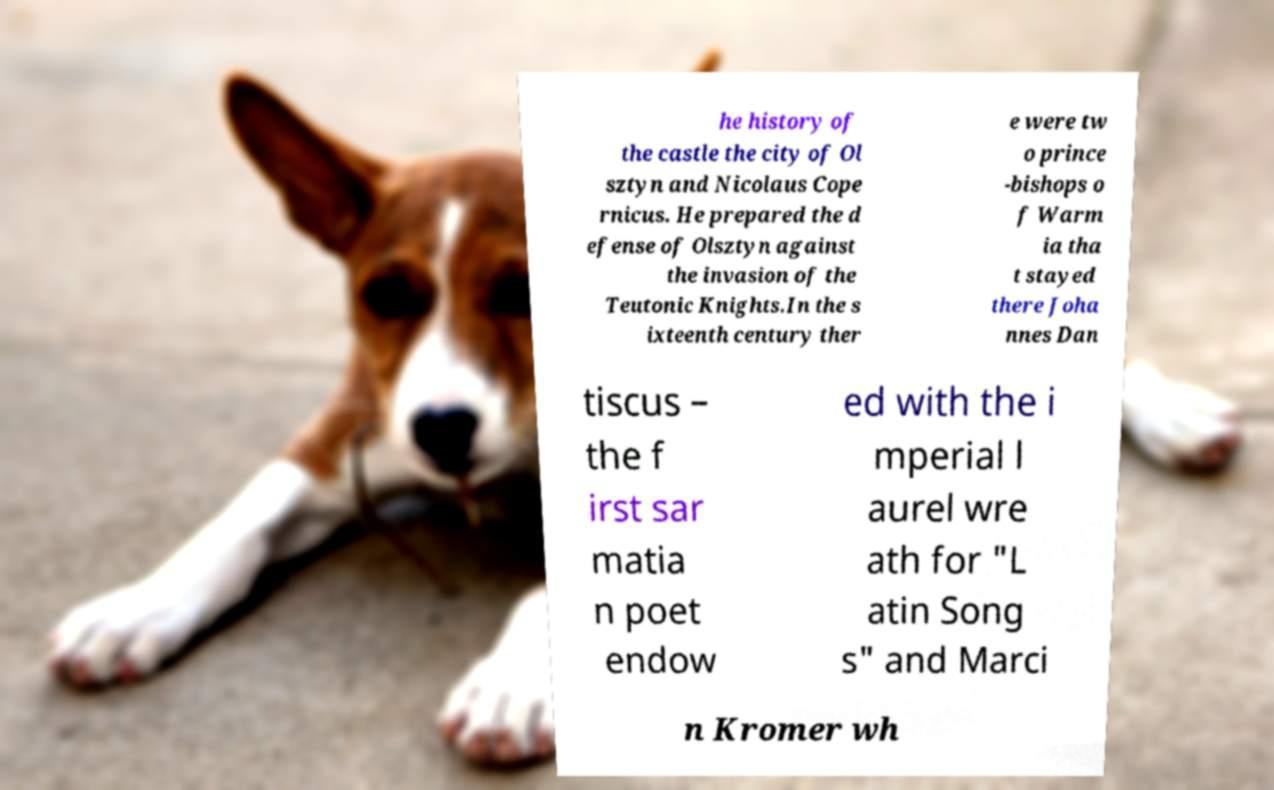I need the written content from this picture converted into text. Can you do that? he history of the castle the city of Ol sztyn and Nicolaus Cope rnicus. He prepared the d efense of Olsztyn against the invasion of the Teutonic Knights.In the s ixteenth century ther e were tw o prince -bishops o f Warm ia tha t stayed there Joha nnes Dan tiscus – the f irst sar matia n poet endow ed with the i mperial l aurel wre ath for "L atin Song s" and Marci n Kromer wh 